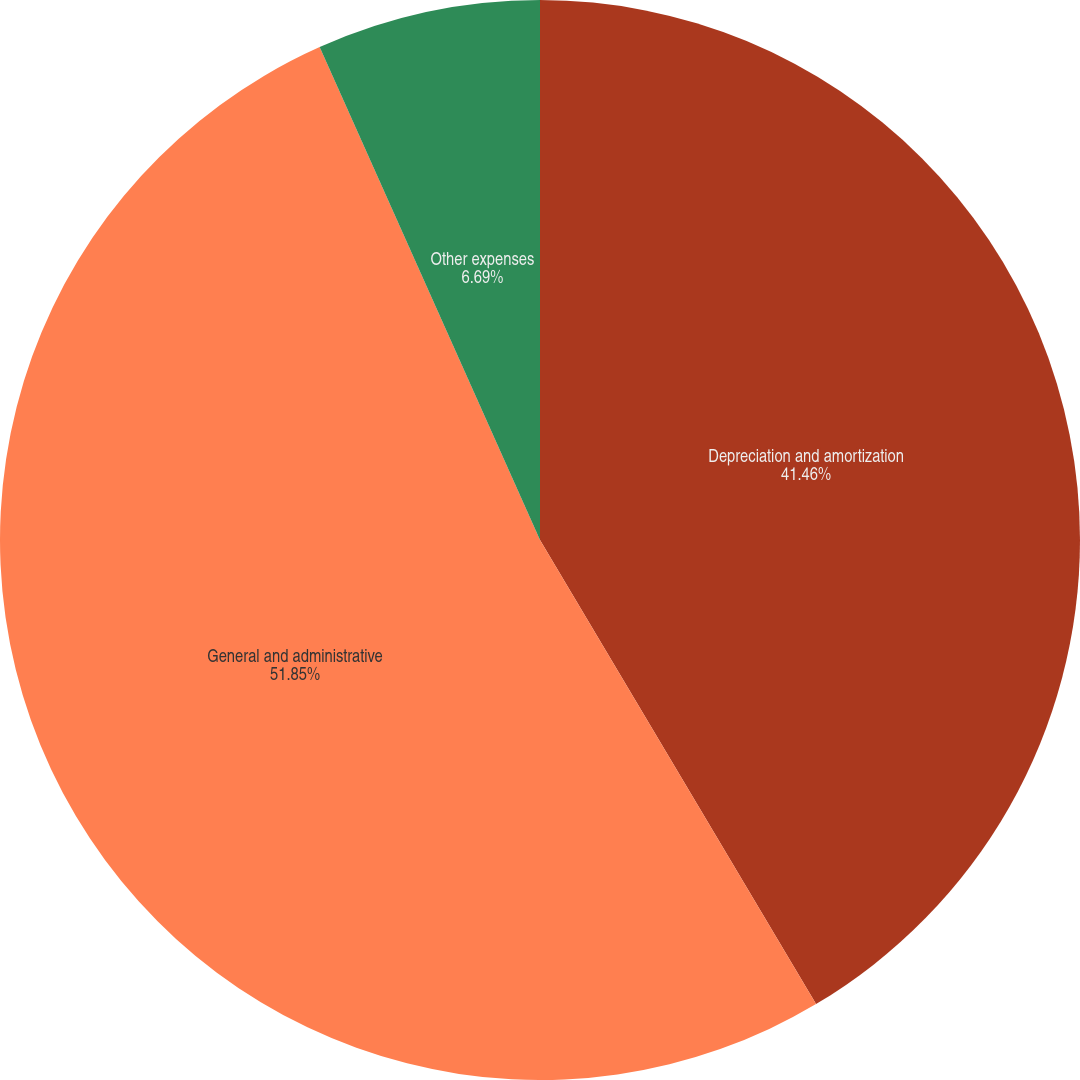<chart> <loc_0><loc_0><loc_500><loc_500><pie_chart><fcel>Depreciation and amortization<fcel>General and administrative<fcel>Other expenses<nl><fcel>41.46%<fcel>51.85%<fcel>6.69%<nl></chart> 